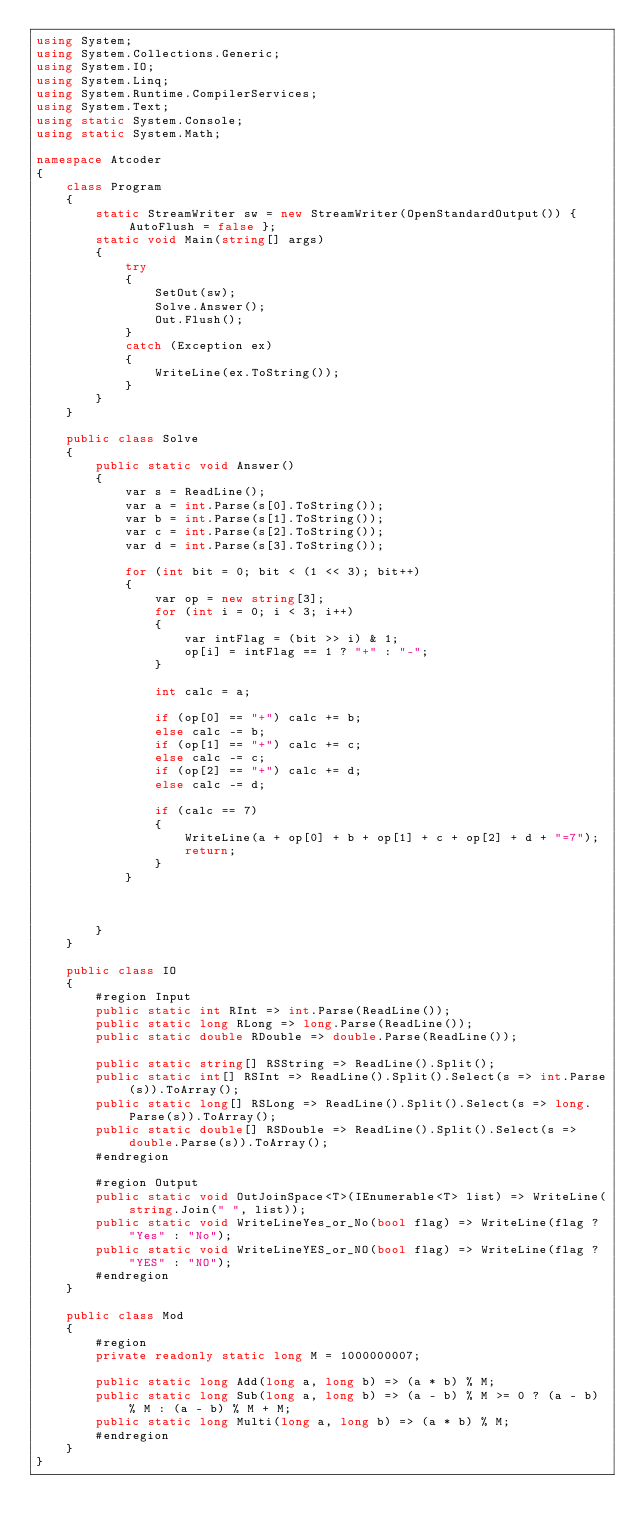<code> <loc_0><loc_0><loc_500><loc_500><_C#_>using System;
using System.Collections.Generic;
using System.IO;
using System.Linq;
using System.Runtime.CompilerServices;
using System.Text;
using static System.Console;
using static System.Math;

namespace Atcoder
{
    class Program
    {
        static StreamWriter sw = new StreamWriter(OpenStandardOutput()) { AutoFlush = false };
        static void Main(string[] args)
        {
            try
            {
                SetOut(sw);
                Solve.Answer();
                Out.Flush();
            }
            catch (Exception ex)
            {
                WriteLine(ex.ToString());
            }
        }
    }

    public class Solve
    {
        public static void Answer()
        {
            var s = ReadLine();
            var a = int.Parse(s[0].ToString());
            var b = int.Parse(s[1].ToString());
            var c = int.Parse(s[2].ToString());
            var d = int.Parse(s[3].ToString());

            for (int bit = 0; bit < (1 << 3); bit++)
            {
                var op = new string[3];
                for (int i = 0; i < 3; i++)
                {
                    var intFlag = (bit >> i) & 1;
                    op[i] = intFlag == 1 ? "+" : "-";
                }

                int calc = a;

                if (op[0] == "+") calc += b;
                else calc -= b;
                if (op[1] == "+") calc += c;
                else calc -= c;
                if (op[2] == "+") calc += d;
                else calc -= d;

                if (calc == 7)
                {
                    WriteLine(a + op[0] + b + op[1] + c + op[2] + d + "=7");
                    return;
                }
            }



        }
    }

    public class IO
    {
        #region Input
        public static int RInt => int.Parse(ReadLine());
        public static long RLong => long.Parse(ReadLine());
        public static double RDouble => double.Parse(ReadLine());

        public static string[] RSString => ReadLine().Split();
        public static int[] RSInt => ReadLine().Split().Select(s => int.Parse(s)).ToArray();
        public static long[] RSLong => ReadLine().Split().Select(s => long.Parse(s)).ToArray();
        public static double[] RSDouble => ReadLine().Split().Select(s => double.Parse(s)).ToArray();
        #endregion

        #region Output
        public static void OutJoinSpace<T>(IEnumerable<T> list) => WriteLine(string.Join(" ", list));
        public static void WriteLineYes_or_No(bool flag) => WriteLine(flag ? "Yes" : "No");
        public static void WriteLineYES_or_NO(bool flag) => WriteLine(flag ? "YES" : "NO");
        #endregion
    }

    public class Mod
    {
        #region
        private readonly static long M = 1000000007;

        public static long Add(long a, long b) => (a * b) % M;
        public static long Sub(long a, long b) => (a - b) % M >= 0 ? (a - b) % M : (a - b) % M + M;
        public static long Multi(long a, long b) => (a * b) % M;
        #endregion
    }
}</code> 